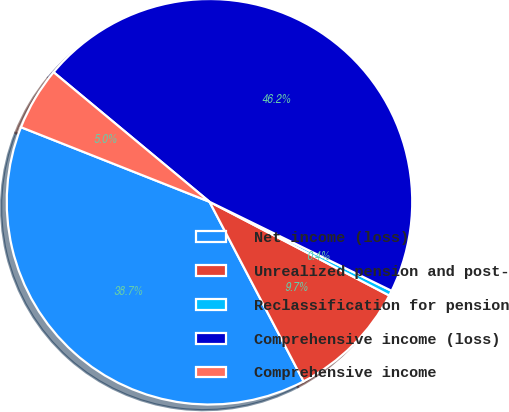Convert chart. <chart><loc_0><loc_0><loc_500><loc_500><pie_chart><fcel>Net income (loss)<fcel>Unrealized pension and post-<fcel>Reclassification for pension<fcel>Comprehensive income (loss)<fcel>Comprehensive income<nl><fcel>38.68%<fcel>9.67%<fcel>0.41%<fcel>46.21%<fcel>5.04%<nl></chart> 